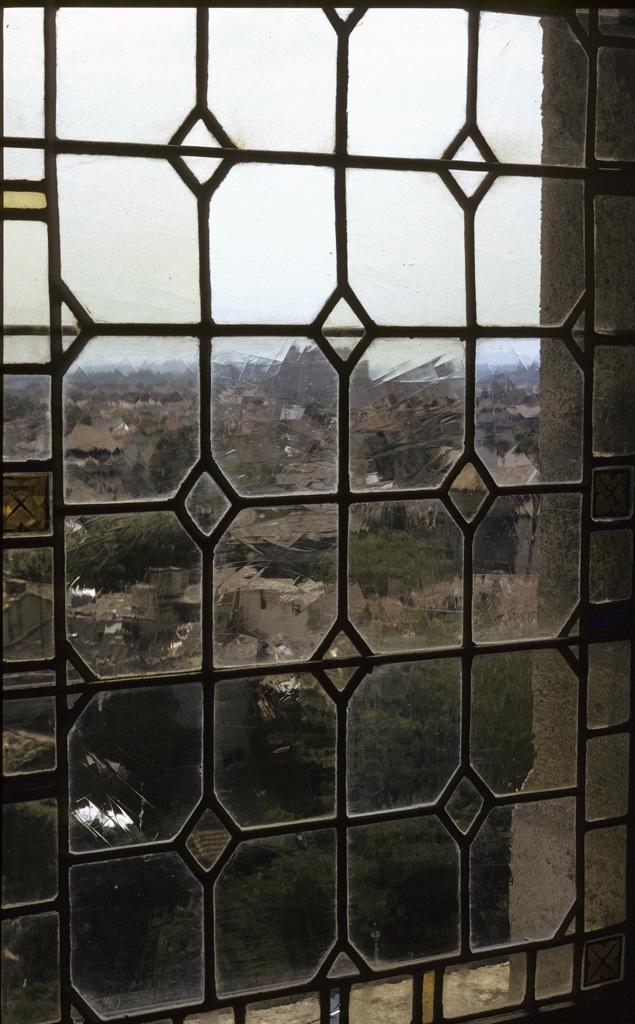How would you summarize this image in a sentence or two? In this picture there are buildings and trees. At the top there is sky. In the foreground there is a window. At the back there might be mountains. 